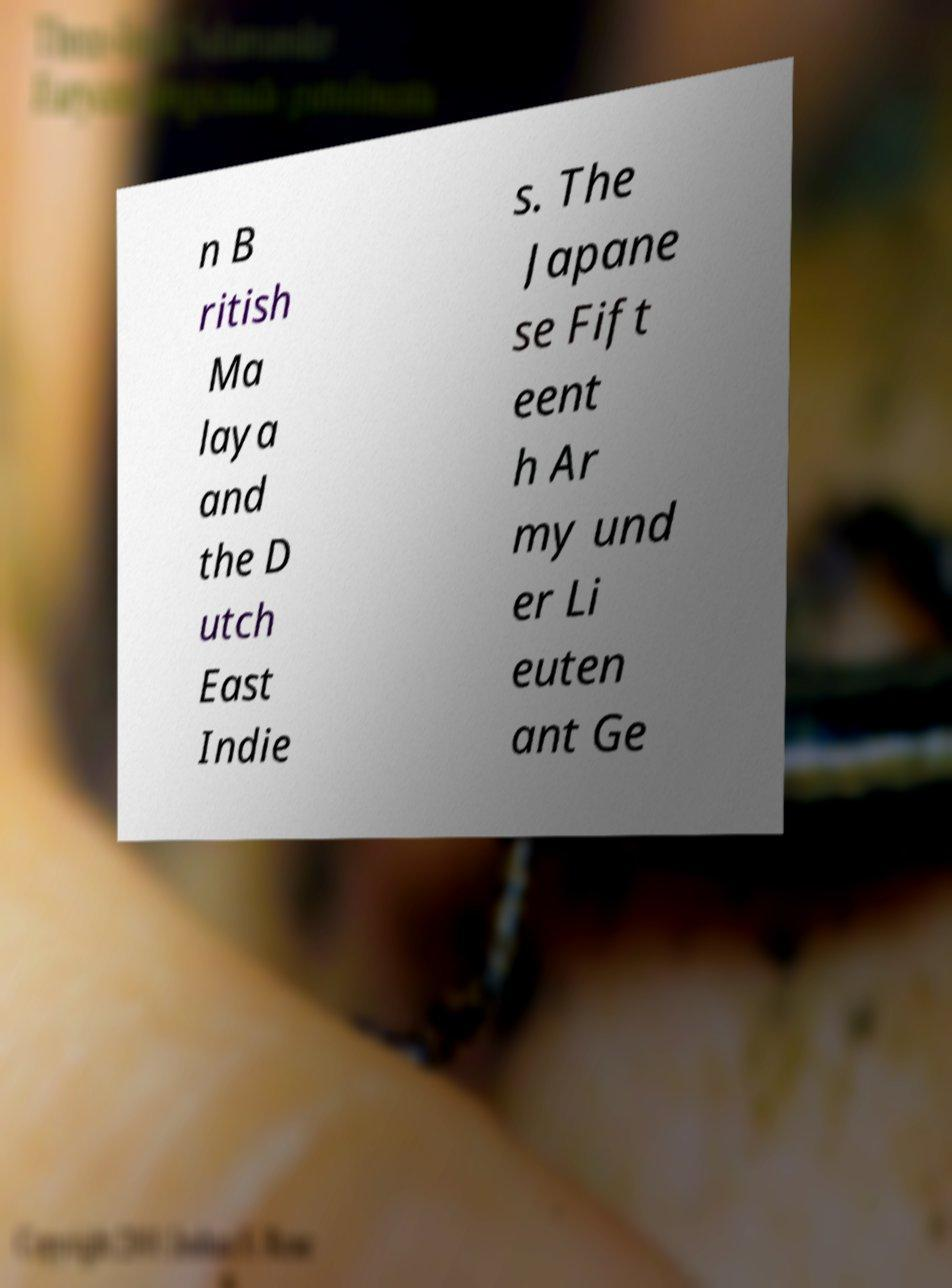I need the written content from this picture converted into text. Can you do that? n B ritish Ma laya and the D utch East Indie s. The Japane se Fift eent h Ar my und er Li euten ant Ge 